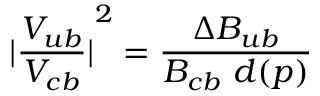<formula> <loc_0><loc_0><loc_500><loc_500>{ | { \frac { V _ { u b } } { V _ { c b } } } | } ^ { 2 } = { \frac { \Delta B _ { u b } } { B _ { c b } d ( p ) } }</formula> 